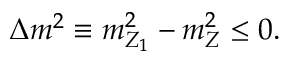Convert formula to latex. <formula><loc_0><loc_0><loc_500><loc_500>\Delta m ^ { 2 } \equiv m _ { Z _ { 1 } } ^ { 2 } - m _ { Z } ^ { 2 } \leq 0 .</formula> 